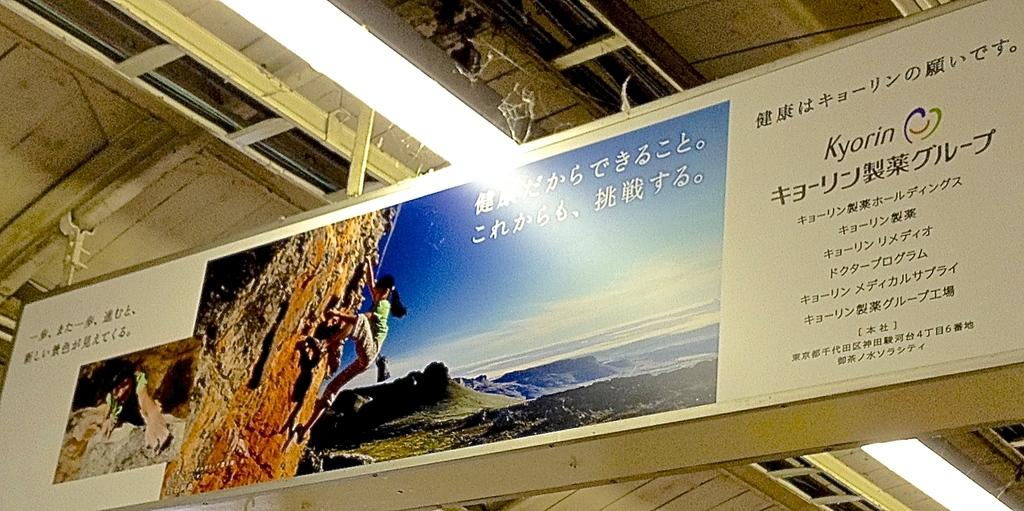<image>
Relay a brief, clear account of the picture shown. A billboard advertisement of a rock climber and the word Kyorin on it. 